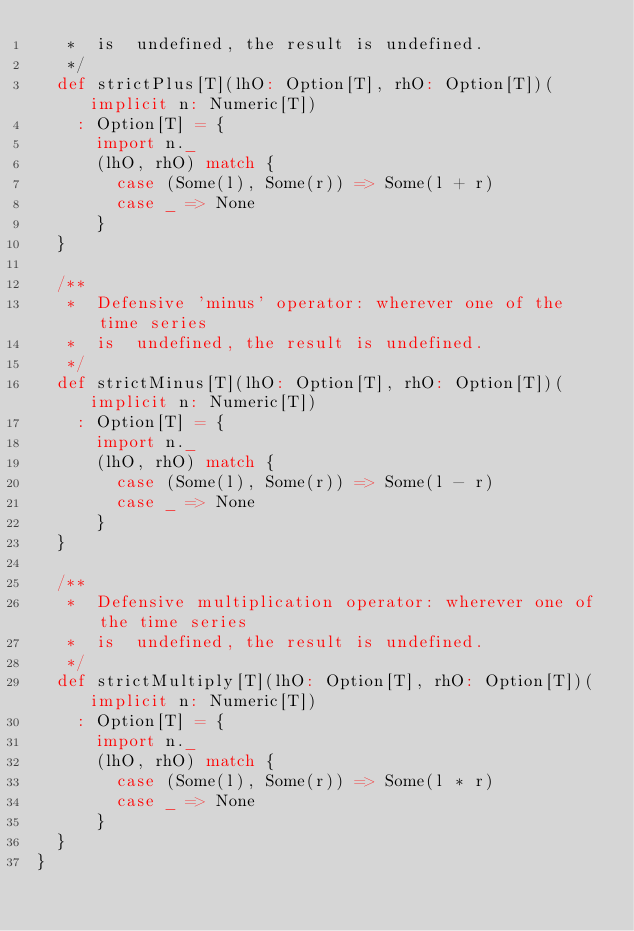Convert code to text. <code><loc_0><loc_0><loc_500><loc_500><_Scala_>   *  is  undefined, the result is undefined.
   */
  def strictPlus[T](lhO: Option[T], rhO: Option[T])(implicit n: Numeric[T])
    : Option[T] = {
      import n._
      (lhO, rhO) match {
        case (Some(l), Some(r)) => Some(l + r)
        case _ => None
      }
  }
  
  /** 
   *  Defensive 'minus' operator: wherever one of the time series 
   *  is  undefined, the result is undefined.
   */
  def strictMinus[T](lhO: Option[T], rhO: Option[T])(implicit n: Numeric[T])
    : Option[T] = { 
      import n._
      (lhO, rhO) match {
        case (Some(l), Some(r)) => Some(l - r)
        case _ => None
      }
  }
  
  /** 
   *  Defensive multiplication operator: wherever one of the time series
   *  is  undefined, the result is undefined.
   */
  def strictMultiply[T](lhO: Option[T], rhO: Option[T])(implicit n: Numeric[T])
    : Option[T] = { 
      import n._
      (lhO, rhO) match {
        case (Some(l), Some(r)) => Some(l * r)
        case _ => None
      }
  }
}</code> 